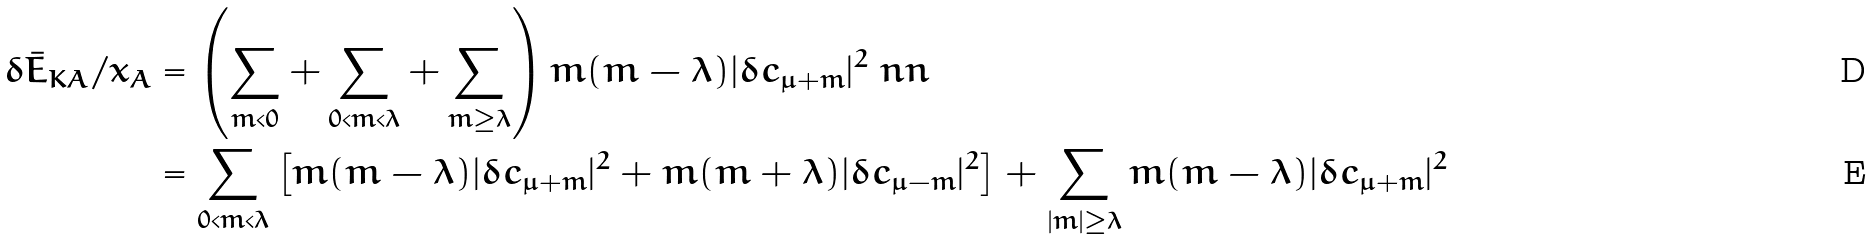<formula> <loc_0><loc_0><loc_500><loc_500>\delta \bar { E } _ { K A } / x _ { A } & = \left ( \sum _ { m < 0 } + \sum _ { 0 < m < \lambda } + \sum _ { m \geq \lambda } \right ) m ( m - \lambda ) | \delta c _ { \mu + m } | ^ { 2 } \ n n \\ & = \sum _ { 0 < m < \lambda } \left [ m ( m - \lambda ) | \delta c _ { \mu + m } | ^ { 2 } + m ( m + \lambda ) | \delta c _ { \mu - m } | ^ { 2 } \right ] + \sum _ { | m | \geq \lambda } m ( m - \lambda ) | \delta c _ { \mu + m } | ^ { 2 }</formula> 